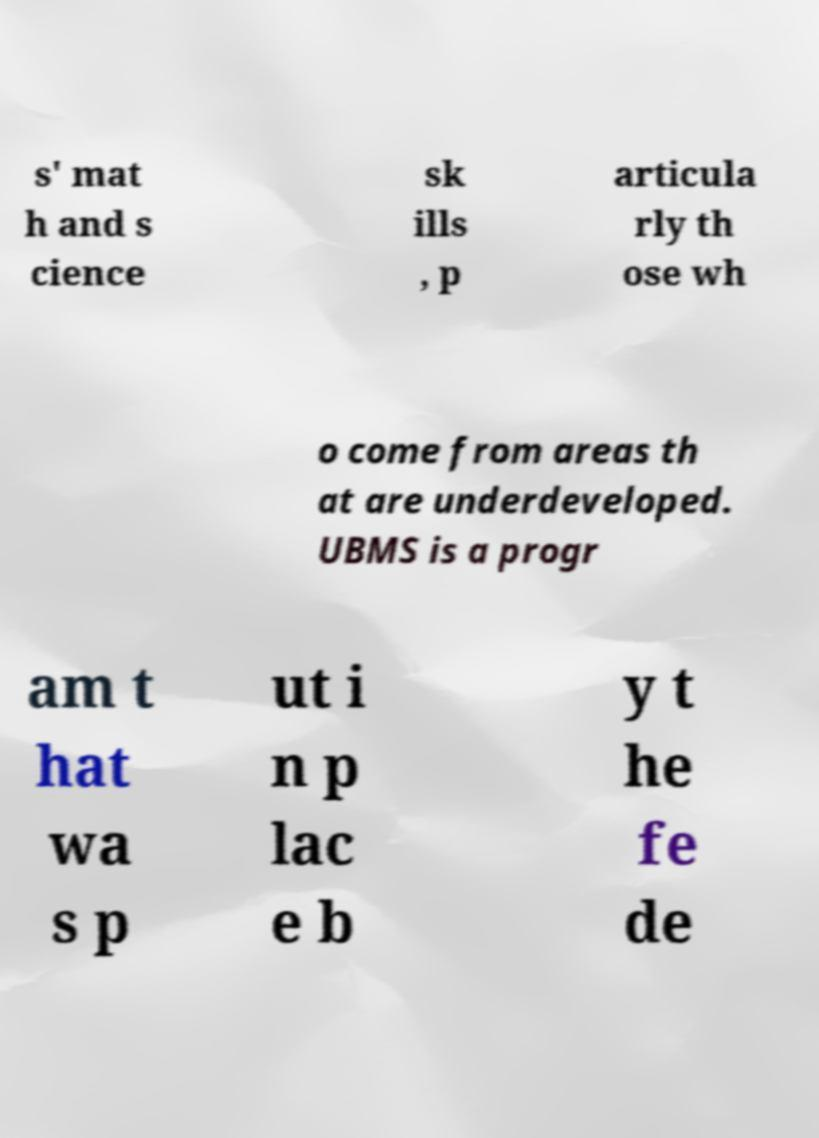What messages or text are displayed in this image? I need them in a readable, typed format. s' mat h and s cience sk ills , p articula rly th ose wh o come from areas th at are underdeveloped. UBMS is a progr am t hat wa s p ut i n p lac e b y t he fe de 